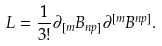Convert formula to latex. <formula><loc_0><loc_0><loc_500><loc_500>L = { \frac { 1 } { 3 ! } } \partial _ { [ m } B _ { n p ] } \partial ^ { [ m } B ^ { n p ] } .</formula> 